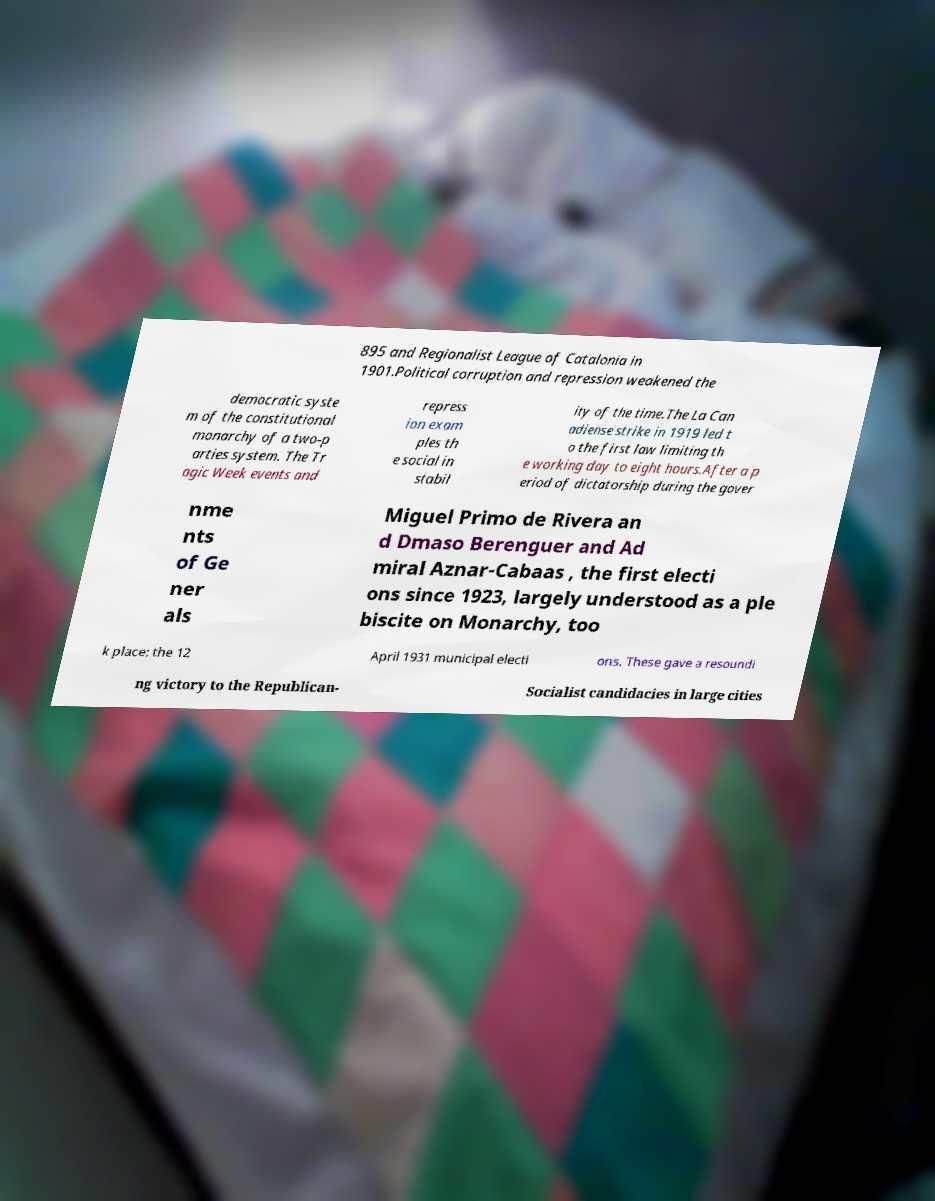Can you accurately transcribe the text from the provided image for me? 895 and Regionalist League of Catalonia in 1901.Political corruption and repression weakened the democratic syste m of the constitutional monarchy of a two-p arties system. The Tr agic Week events and repress ion exam ples th e social in stabil ity of the time.The La Can adiense strike in 1919 led t o the first law limiting th e working day to eight hours.After a p eriod of dictatorship during the gover nme nts of Ge ner als Miguel Primo de Rivera an d Dmaso Berenguer and Ad miral Aznar-Cabaas , the first electi ons since 1923, largely understood as a ple biscite on Monarchy, too k place: the 12 April 1931 municipal electi ons. These gave a resoundi ng victory to the Republican- Socialist candidacies in large cities 